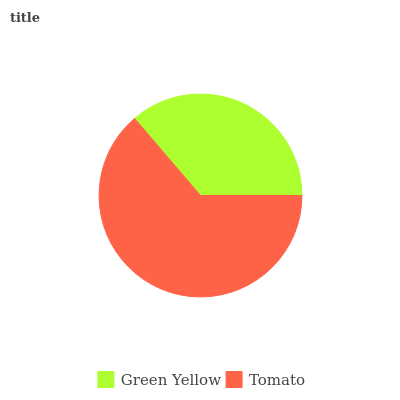Is Green Yellow the minimum?
Answer yes or no. Yes. Is Tomato the maximum?
Answer yes or no. Yes. Is Tomato the minimum?
Answer yes or no. No. Is Tomato greater than Green Yellow?
Answer yes or no. Yes. Is Green Yellow less than Tomato?
Answer yes or no. Yes. Is Green Yellow greater than Tomato?
Answer yes or no. No. Is Tomato less than Green Yellow?
Answer yes or no. No. Is Tomato the high median?
Answer yes or no. Yes. Is Green Yellow the low median?
Answer yes or no. Yes. Is Green Yellow the high median?
Answer yes or no. No. Is Tomato the low median?
Answer yes or no. No. 